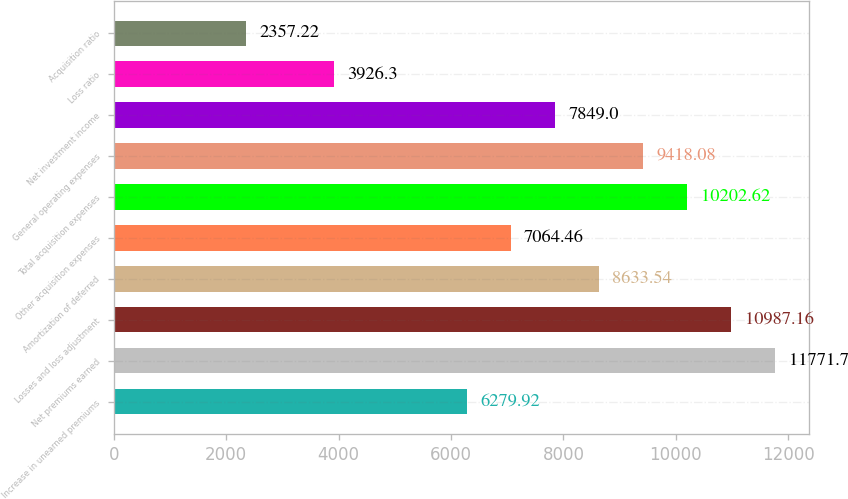Convert chart to OTSL. <chart><loc_0><loc_0><loc_500><loc_500><bar_chart><fcel>Increase in unearned premiums<fcel>Net premiums earned<fcel>Losses and loss adjustment<fcel>Amortization of deferred<fcel>Other acquisition expenses<fcel>Total acquisition expenses<fcel>General operating expenses<fcel>Net investment income<fcel>Loss ratio<fcel>Acquisition ratio<nl><fcel>6279.92<fcel>11771.7<fcel>10987.2<fcel>8633.54<fcel>7064.46<fcel>10202.6<fcel>9418.08<fcel>7849<fcel>3926.3<fcel>2357.22<nl></chart> 